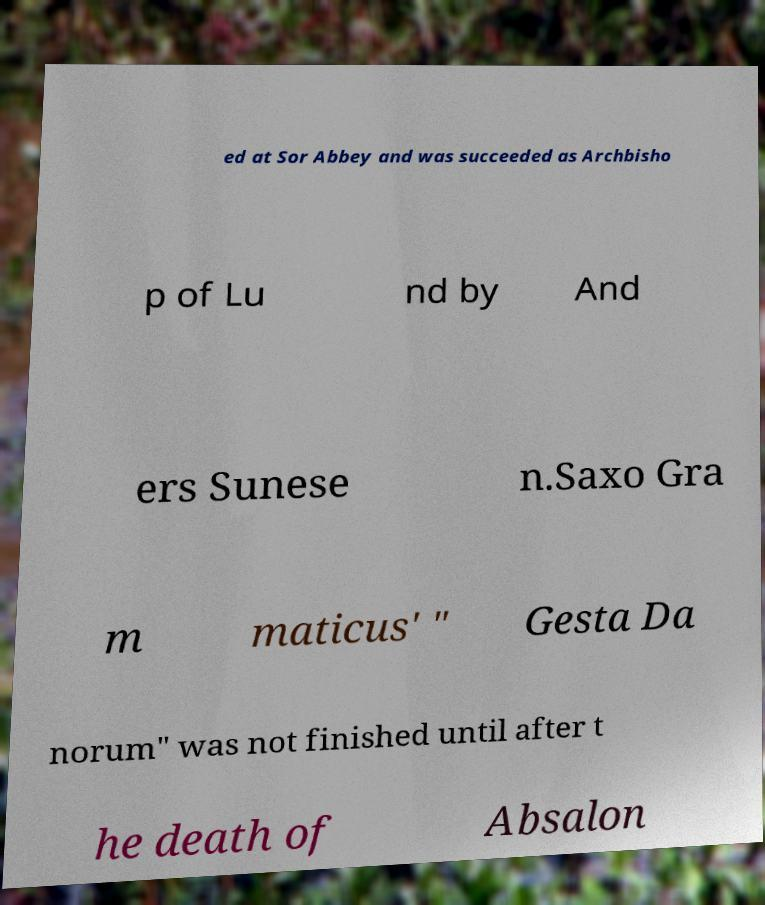For documentation purposes, I need the text within this image transcribed. Could you provide that? ed at Sor Abbey and was succeeded as Archbisho p of Lu nd by And ers Sunese n.Saxo Gra m maticus' " Gesta Da norum" was not finished until after t he death of Absalon 